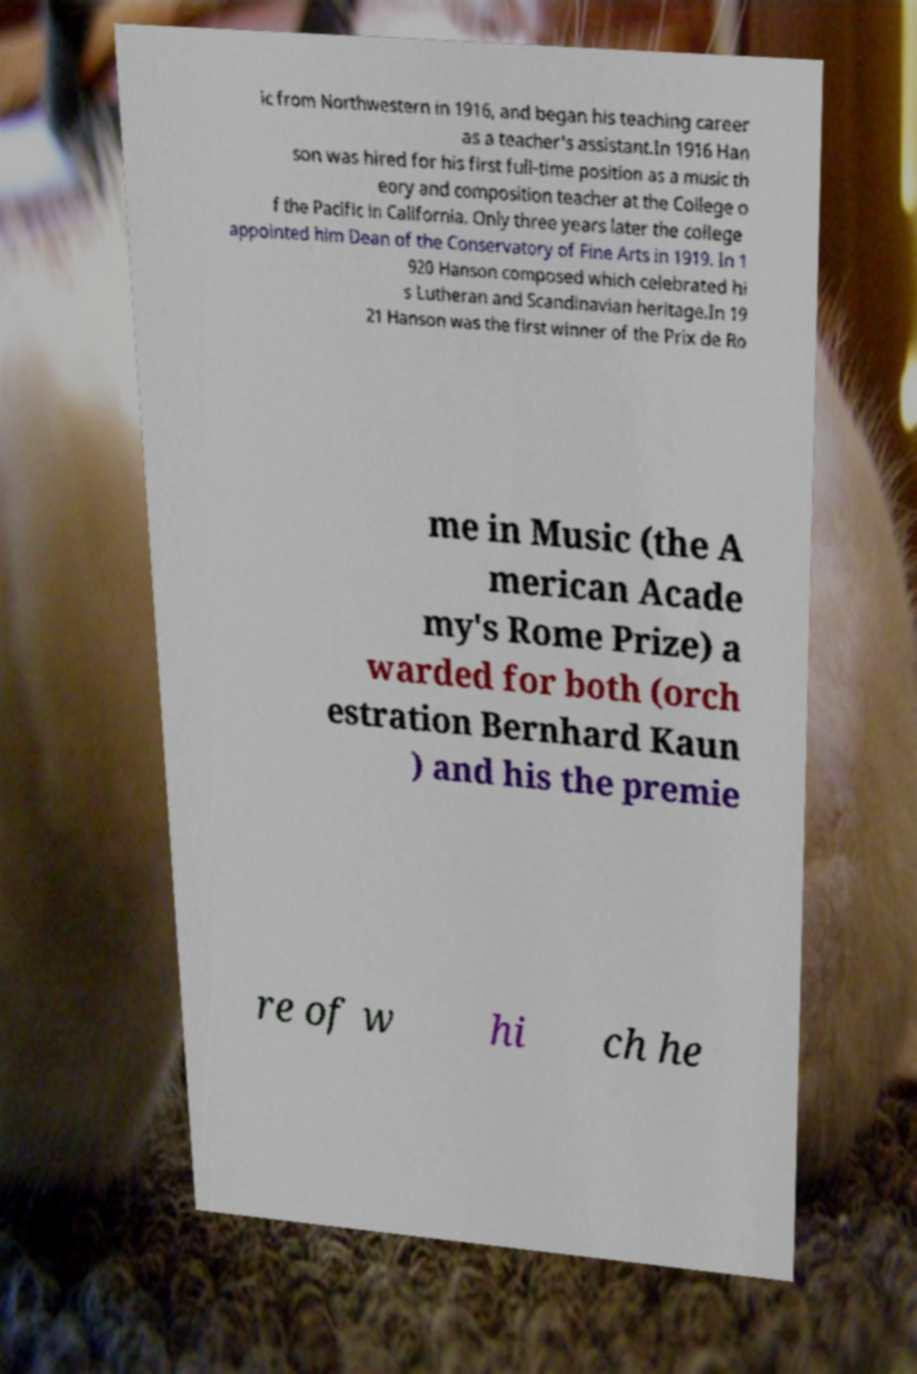Can you read and provide the text displayed in the image?This photo seems to have some interesting text. Can you extract and type it out for me? ic from Northwestern in 1916, and began his teaching career as a teacher's assistant.In 1916 Han son was hired for his first full-time position as a music th eory and composition teacher at the College o f the Pacific in California. Only three years later the college appointed him Dean of the Conservatory of Fine Arts in 1919. In 1 920 Hanson composed which celebrated hi s Lutheran and Scandinavian heritage.In 19 21 Hanson was the first winner of the Prix de Ro me in Music (the A merican Acade my's Rome Prize) a warded for both (orch estration Bernhard Kaun ) and his the premie re of w hi ch he 